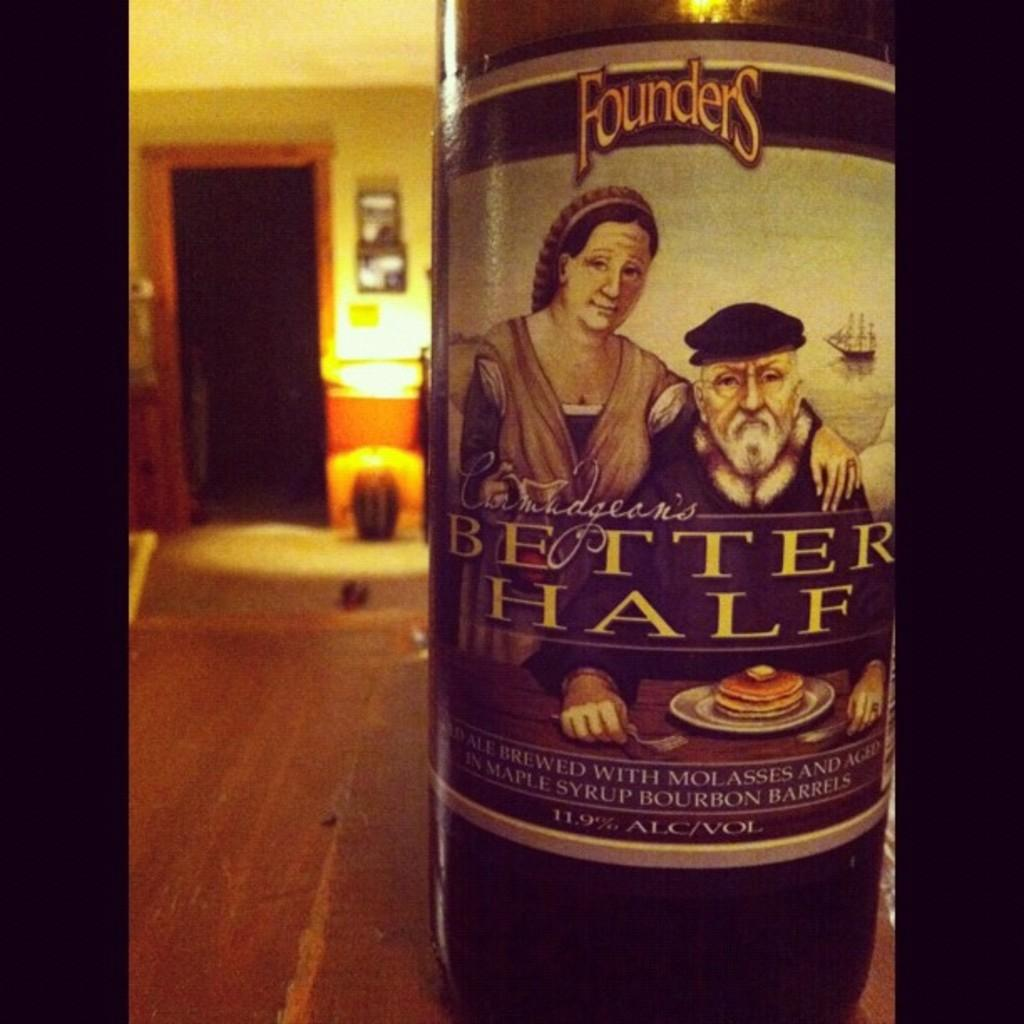What object can be seen in the image? There is a bottle in the image. What is depicted on the bottle? There are two persons on the bottle. What else is present on the bottle besides the figures? There is a plate with food on the bottle. What can be seen in the background of the image? There is a wall and frames in the background of the image. What type of tooth is visible in the image? There is no tooth present in the image. What kind of ship can be seen sailing in the background of the image? There is no ship visible in the image; it only features a bottle, figures, food, a wall, and frames. 